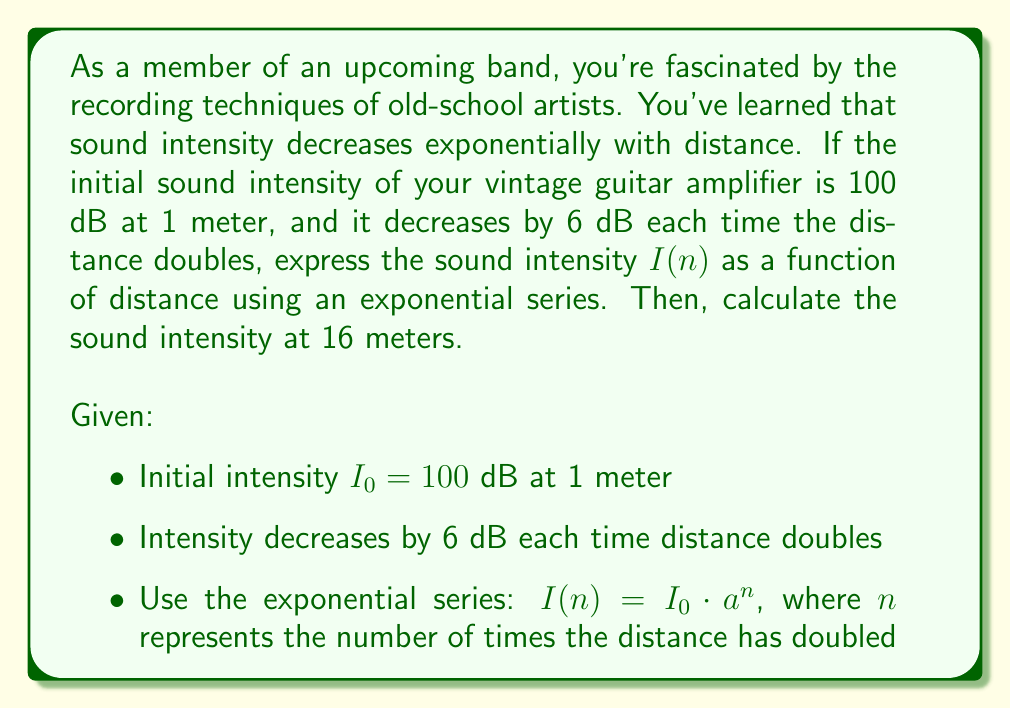Show me your answer to this math problem. Let's approach this step-by-step:

1) First, we need to find the value of $a$ in the exponential series $I(n) = I_0 \cdot a^n$.
   We know that each time the distance doubles, the intensity decreases by 6 dB.
   This means that $a = 2^{-6/10} \approx 0.7943$ (because $10^{-6/10} = 2^{-6/10}$)

2) Now we can express the intensity as a function of $n$:
   $$I(n) = 100 \cdot (0.7943)^n$$

3) To find $n$ for a distance of 16 meters, we need to determine how many times we've doubled the distance from 1 meter:
   $1 \rightarrow 2 \rightarrow 4 \rightarrow 8 \rightarrow 16$
   We've doubled the distance 4 times, so $n = 4$

4) Now we can calculate the intensity at 16 meters:
   $$I(4) = 100 \cdot (0.7943)^4 \approx 39.81 \text{ dB}$$
Answer: The sound intensity as a function of distance can be expressed as:
$$I(n) = 100 \cdot (0.7943)^n$$
where $n$ is the number of times the distance has doubled from 1 meter.

At 16 meters (which is 4 doublings from 1 meter), the sound intensity is approximately 39.81 dB. 